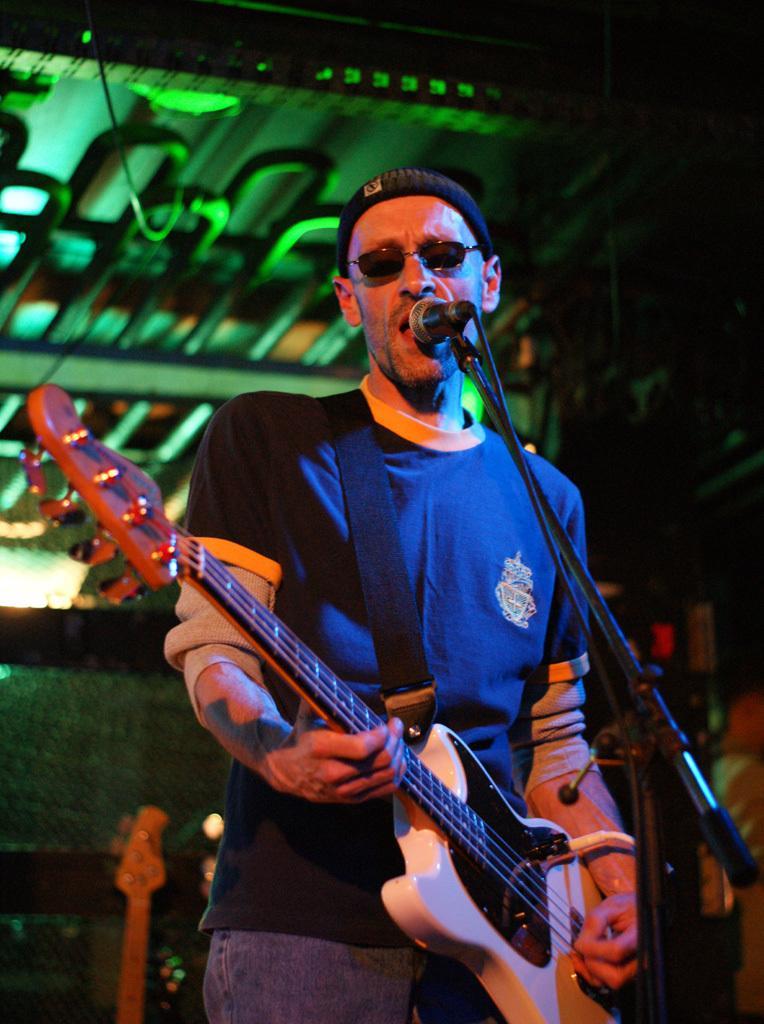Could you give a brief overview of what you see in this image? In this image I can see one person is standing and holding the guitar. In front I can see the mic and the stand. Back I can see few objects and green color lighting. 